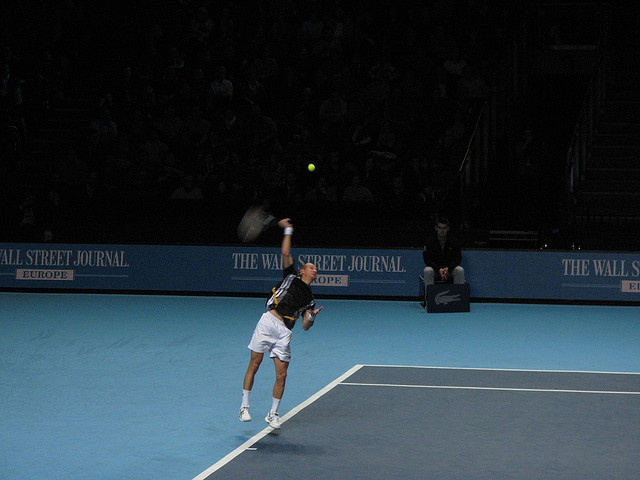Describe the objects in this image and their specific colors. I can see people in black, gray, and lightgray tones, people in black, gray, and purple tones, tennis racket in black tones, people in black tones, and people in black tones in this image. 